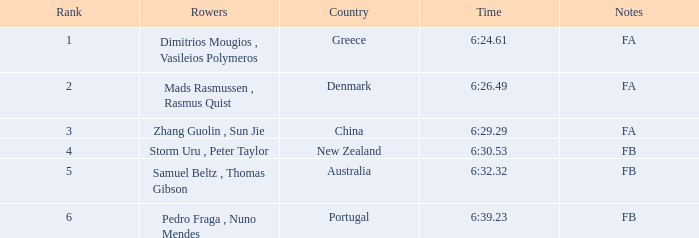61? Dimitrios Mougios , Vasileios Polymeros. 